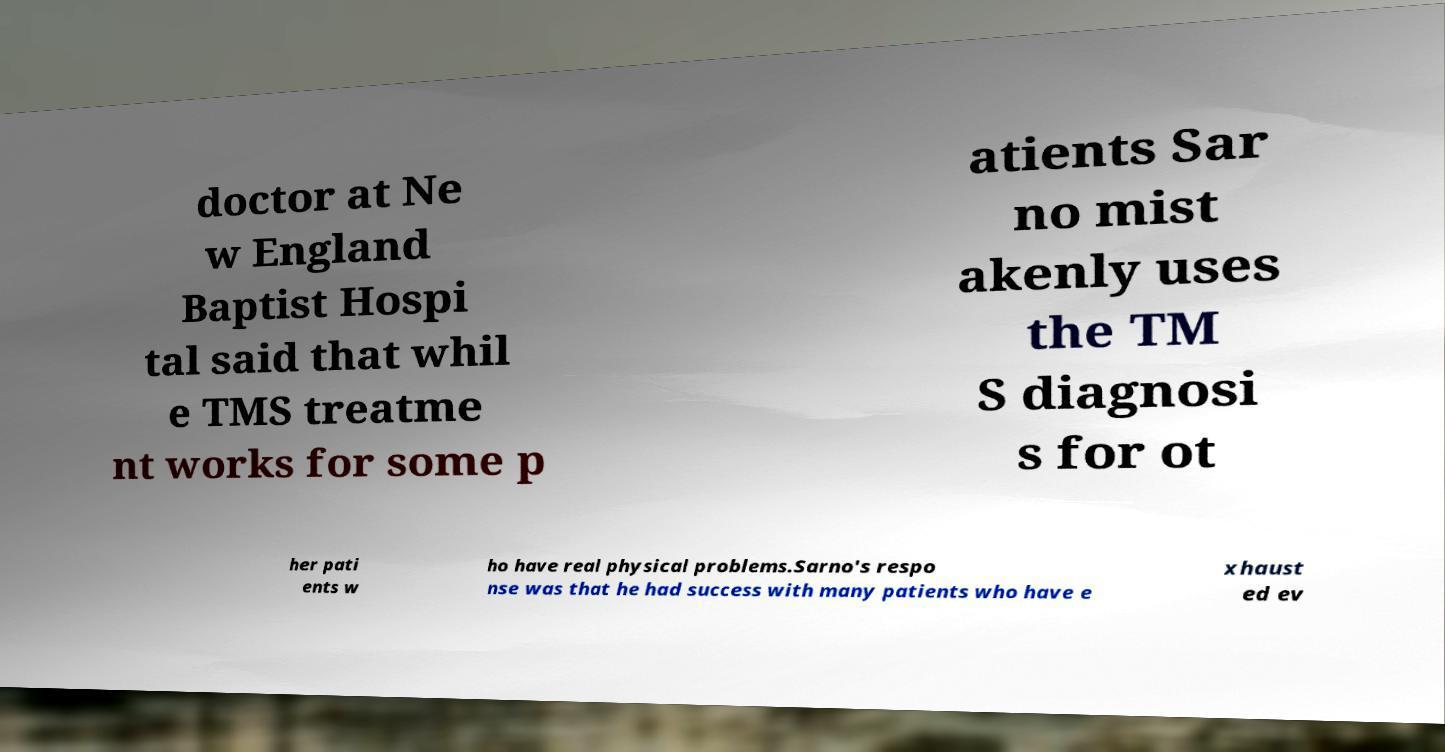Can you read and provide the text displayed in the image?This photo seems to have some interesting text. Can you extract and type it out for me? doctor at Ne w England Baptist Hospi tal said that whil e TMS treatme nt works for some p atients Sar no mist akenly uses the TM S diagnosi s for ot her pati ents w ho have real physical problems.Sarno's respo nse was that he had success with many patients who have e xhaust ed ev 